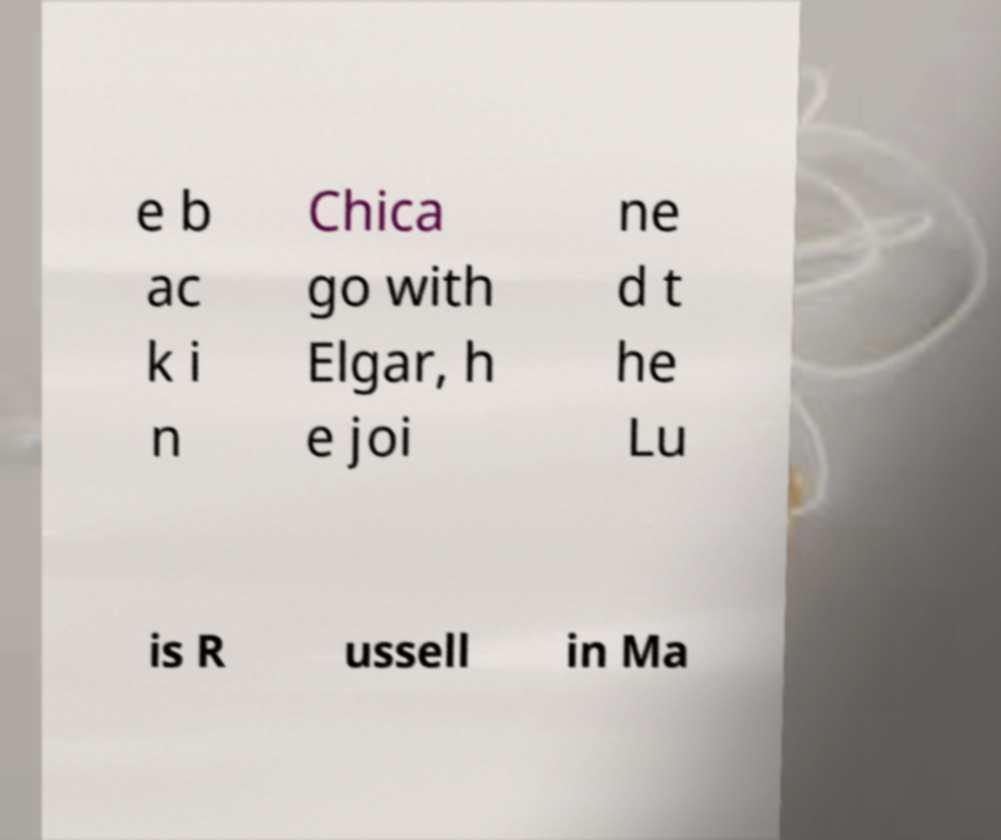There's text embedded in this image that I need extracted. Can you transcribe it verbatim? e b ac k i n Chica go with Elgar, h e joi ne d t he Lu is R ussell in Ma 